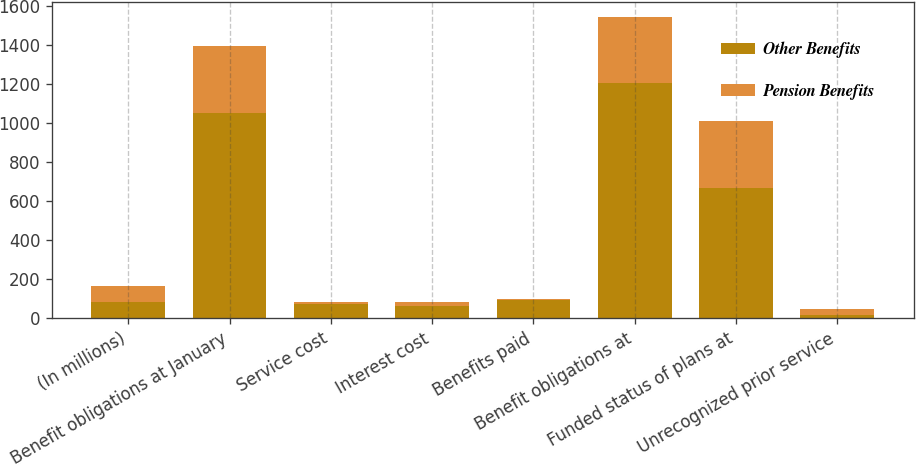<chart> <loc_0><loc_0><loc_500><loc_500><stacked_bar_chart><ecel><fcel>(In millions)<fcel>Benefit obligations at January<fcel>Service cost<fcel>Interest cost<fcel>Benefits paid<fcel>Benefit obligations at<fcel>Funded status of plans at<fcel>Unrecognized prior service<nl><fcel>Other Benefits<fcel>81<fcel>1051<fcel>70<fcel>64<fcel>92<fcel>1203<fcel>668<fcel>18<nl><fcel>Pension Benefits<fcel>81<fcel>346<fcel>14<fcel>20<fcel>5<fcel>341<fcel>341<fcel>26<nl></chart> 